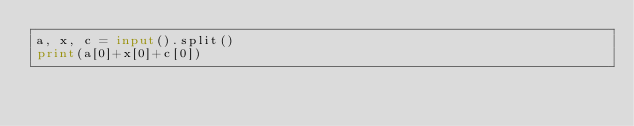<code> <loc_0><loc_0><loc_500><loc_500><_Python_>a, x, c = input().split()
print(a[0]+x[0]+c[0])</code> 